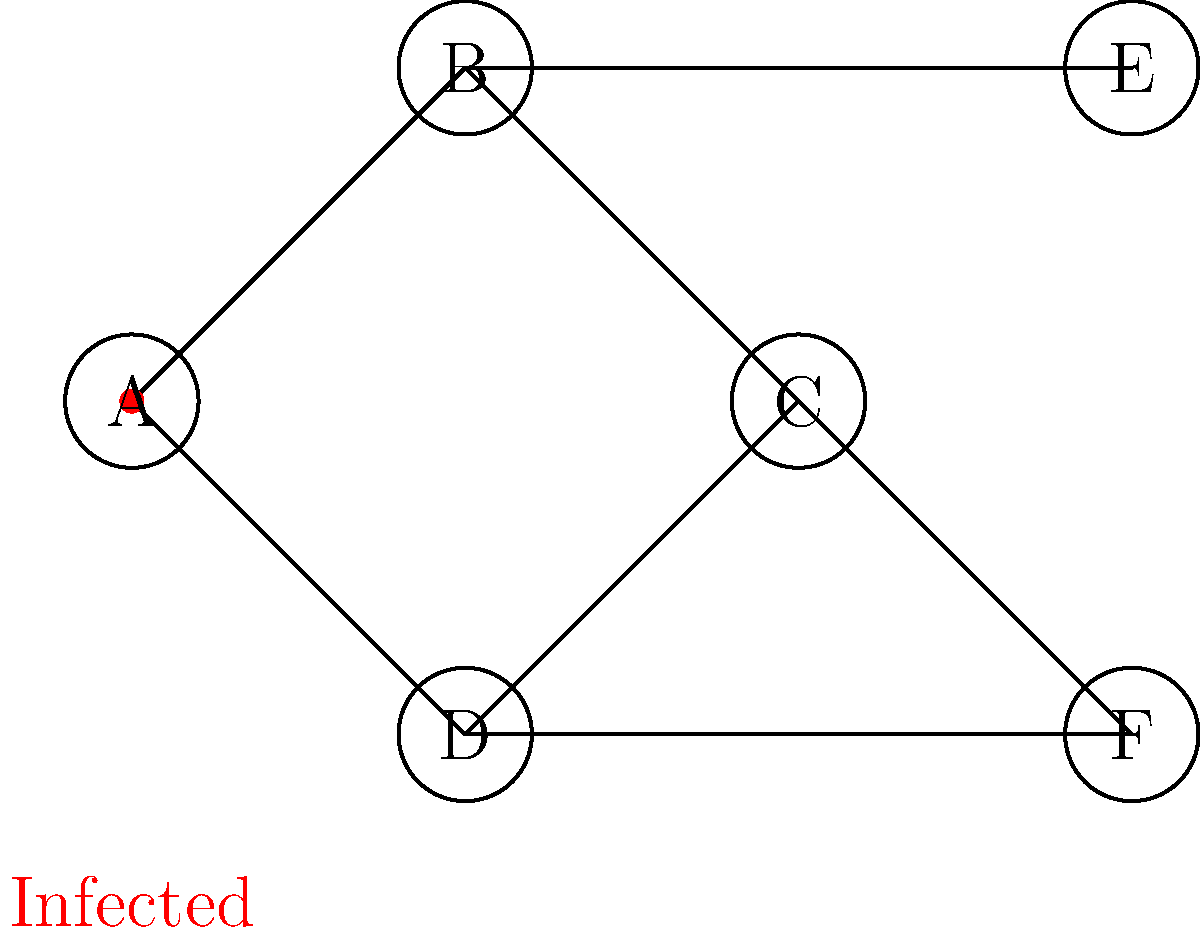In a population network, a virus starts spreading from individual A. If the virus has a 50% chance of transmitting to each connected individual in one time step, what is the probability that both individuals E and F will be infected after two time steps? Let's approach this step-by-step:

1) First, we need to identify the paths to E and F:
   - To reach E: A → B → E
   - To reach F: A → C → F or A → D → F

2) For E to be infected after two steps:
   - The virus must transmit from A to B in step 1 (50% chance)
   - Then from B to E in step 2 (50% chance)
   - Probability = $0.5 \times 0.5 = 0.25$ or 25%

3) For F to be infected after two steps:
   - The virus must transmit from A to C or D in step 1
   - Then from C or D to F in step 2
   - Probability of infecting C or D in step 1 = $1 - (1-0.5)^2 = 0.75$ or 75%
   - Probability of then infecting F = $1 - (1-0.5)^2 = 0.75$ or 75%
   - Total probability for F = $0.75 \times 0.75 = 0.5625$ or 56.25%

4) For both E and F to be infected, these events must occur independently:
   - Probability = Prob(E infected) × Prob(F infected)
   - $P(\text{both E and F infected}) = 0.25 \times 0.5625 = 0.140625$

5) Convert to a percentage: $0.140625 \times 100\% = 14.0625\%$
Answer: 14.0625% 